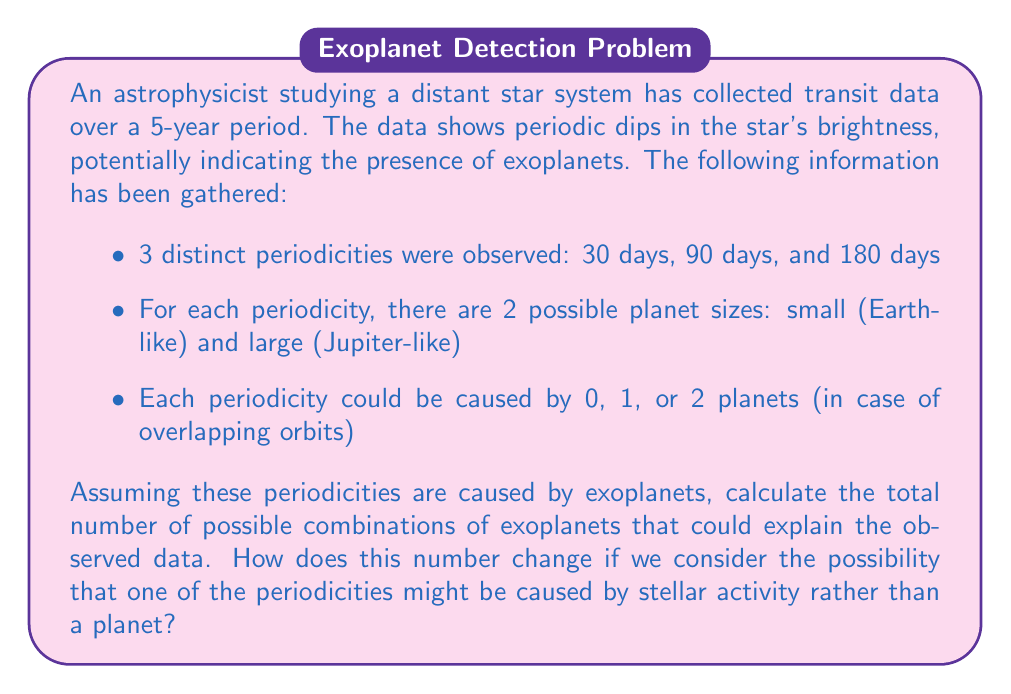Can you answer this question? Let's approach this problem step-by-step:

1) First, let's consider each periodicity independently:
   - For each periodicity, we have 3 possibilities: 0 planets, 1 small planet, 1 large planet, or 2 planets (either small-small, small-large, or large-large).
   - This gives us 5 possibilities for each periodicity: $0, S, L, SS, SL, LL$ where S = small and L = large.

2) Now, we need to consider all combinations of these possibilities across the three periodicities. This is a multiplication principle problem:
   $$ \text{Total combinations} = 5 \times 5 \times 5 = 125 $$

3) This means there are 125 possible combinations of exoplanets that could explain the observed data.

4) Now, let's consider the case where one of the periodicities might be caused by stellar activity:
   - In this case, we need to consider 4 scenarios:
     a) All periodicities are caused by planets
     b) 30-day periodicity is stellar activity
     c) 90-day periodicity is stellar activity
     d) 180-day periodicity is stellar activity

5) For scenario a), we already calculated 125 combinations.
   For scenarios b), c), and d), we replace one of the periodicities with a binary choice (stellar activity or not), while the other two periodicities remain as before:
   $$ 2 \times 5 \times 5 = 50 $$

6) The total number of combinations is thus:
   $$ 125 + 50 + 50 + 50 = 275 $$

Therefore, when considering the possibility of stellar activity, the number of possible combinations increases from 125 to 275.
Answer: Without considering stellar activity: 125 combinations
Considering possible stellar activity: 275 combinations 